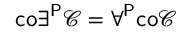<formula> <loc_0><loc_0><loc_500><loc_500>{ c o } \exists ^ { P } { \mathcal { C } } = \forall ^ { P } { c o } { \mathcal { C } }</formula> 